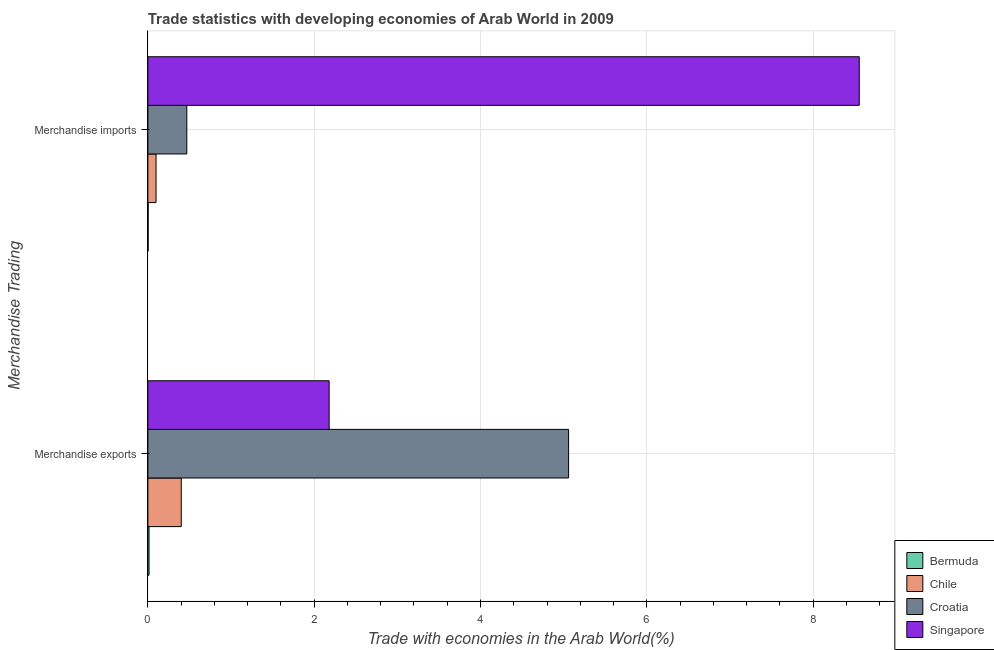How many different coloured bars are there?
Offer a terse response. 4. How many groups of bars are there?
Provide a succinct answer. 2. Are the number of bars per tick equal to the number of legend labels?
Offer a terse response. Yes. Are the number of bars on each tick of the Y-axis equal?
Your response must be concise. Yes. What is the label of the 2nd group of bars from the top?
Give a very brief answer. Merchandise exports. What is the merchandise exports in Croatia?
Give a very brief answer. 5.06. Across all countries, what is the maximum merchandise exports?
Give a very brief answer. 5.06. Across all countries, what is the minimum merchandise imports?
Offer a very short reply. 0. In which country was the merchandise exports maximum?
Your answer should be very brief. Croatia. In which country was the merchandise exports minimum?
Keep it short and to the point. Bermuda. What is the total merchandise exports in the graph?
Your response must be concise. 7.66. What is the difference between the merchandise exports in Croatia and that in Chile?
Your response must be concise. 4.66. What is the difference between the merchandise imports in Croatia and the merchandise exports in Bermuda?
Provide a succinct answer. 0.45. What is the average merchandise exports per country?
Give a very brief answer. 1.91. What is the difference between the merchandise exports and merchandise imports in Chile?
Provide a succinct answer. 0.3. In how many countries, is the merchandise imports greater than 8 %?
Ensure brevity in your answer.  1. What is the ratio of the merchandise exports in Chile to that in Croatia?
Provide a succinct answer. 0.08. Is the merchandise imports in Chile less than that in Croatia?
Ensure brevity in your answer.  Yes. In how many countries, is the merchandise imports greater than the average merchandise imports taken over all countries?
Your response must be concise. 1. What does the 1st bar from the top in Merchandise imports represents?
Ensure brevity in your answer.  Singapore. What does the 2nd bar from the bottom in Merchandise imports represents?
Keep it short and to the point. Chile. How many bars are there?
Make the answer very short. 8. How many countries are there in the graph?
Your response must be concise. 4. Are the values on the major ticks of X-axis written in scientific E-notation?
Provide a short and direct response. No. Does the graph contain grids?
Give a very brief answer. Yes. Where does the legend appear in the graph?
Ensure brevity in your answer.  Bottom right. How many legend labels are there?
Your response must be concise. 4. What is the title of the graph?
Give a very brief answer. Trade statistics with developing economies of Arab World in 2009. Does "Europe(all income levels)" appear as one of the legend labels in the graph?
Keep it short and to the point. No. What is the label or title of the X-axis?
Your response must be concise. Trade with economies in the Arab World(%). What is the label or title of the Y-axis?
Your answer should be compact. Merchandise Trading. What is the Trade with economies in the Arab World(%) of Bermuda in Merchandise exports?
Keep it short and to the point. 0.01. What is the Trade with economies in the Arab World(%) in Chile in Merchandise exports?
Offer a very short reply. 0.4. What is the Trade with economies in the Arab World(%) of Croatia in Merchandise exports?
Your answer should be compact. 5.06. What is the Trade with economies in the Arab World(%) in Singapore in Merchandise exports?
Offer a terse response. 2.18. What is the Trade with economies in the Arab World(%) of Bermuda in Merchandise imports?
Give a very brief answer. 0. What is the Trade with economies in the Arab World(%) of Chile in Merchandise imports?
Offer a terse response. 0.1. What is the Trade with economies in the Arab World(%) of Croatia in Merchandise imports?
Your answer should be compact. 0.47. What is the Trade with economies in the Arab World(%) in Singapore in Merchandise imports?
Your answer should be compact. 8.56. Across all Merchandise Trading, what is the maximum Trade with economies in the Arab World(%) of Bermuda?
Make the answer very short. 0.01. Across all Merchandise Trading, what is the maximum Trade with economies in the Arab World(%) in Chile?
Your answer should be compact. 0.4. Across all Merchandise Trading, what is the maximum Trade with economies in the Arab World(%) of Croatia?
Offer a terse response. 5.06. Across all Merchandise Trading, what is the maximum Trade with economies in the Arab World(%) in Singapore?
Provide a succinct answer. 8.56. Across all Merchandise Trading, what is the minimum Trade with economies in the Arab World(%) of Bermuda?
Ensure brevity in your answer.  0. Across all Merchandise Trading, what is the minimum Trade with economies in the Arab World(%) in Chile?
Make the answer very short. 0.1. Across all Merchandise Trading, what is the minimum Trade with economies in the Arab World(%) in Croatia?
Make the answer very short. 0.47. Across all Merchandise Trading, what is the minimum Trade with economies in the Arab World(%) in Singapore?
Make the answer very short. 2.18. What is the total Trade with economies in the Arab World(%) of Bermuda in the graph?
Ensure brevity in your answer.  0.02. What is the total Trade with economies in the Arab World(%) of Chile in the graph?
Keep it short and to the point. 0.5. What is the total Trade with economies in the Arab World(%) of Croatia in the graph?
Your response must be concise. 5.53. What is the total Trade with economies in the Arab World(%) of Singapore in the graph?
Provide a succinct answer. 10.74. What is the difference between the Trade with economies in the Arab World(%) in Bermuda in Merchandise exports and that in Merchandise imports?
Give a very brief answer. 0.01. What is the difference between the Trade with economies in the Arab World(%) in Chile in Merchandise exports and that in Merchandise imports?
Offer a very short reply. 0.3. What is the difference between the Trade with economies in the Arab World(%) of Croatia in Merchandise exports and that in Merchandise imports?
Your answer should be compact. 4.59. What is the difference between the Trade with economies in the Arab World(%) in Singapore in Merchandise exports and that in Merchandise imports?
Your answer should be compact. -6.38. What is the difference between the Trade with economies in the Arab World(%) of Bermuda in Merchandise exports and the Trade with economies in the Arab World(%) of Chile in Merchandise imports?
Your answer should be compact. -0.08. What is the difference between the Trade with economies in the Arab World(%) of Bermuda in Merchandise exports and the Trade with economies in the Arab World(%) of Croatia in Merchandise imports?
Provide a succinct answer. -0.45. What is the difference between the Trade with economies in the Arab World(%) of Bermuda in Merchandise exports and the Trade with economies in the Arab World(%) of Singapore in Merchandise imports?
Make the answer very short. -8.54. What is the difference between the Trade with economies in the Arab World(%) of Chile in Merchandise exports and the Trade with economies in the Arab World(%) of Croatia in Merchandise imports?
Your response must be concise. -0.07. What is the difference between the Trade with economies in the Arab World(%) in Chile in Merchandise exports and the Trade with economies in the Arab World(%) in Singapore in Merchandise imports?
Offer a terse response. -8.15. What is the difference between the Trade with economies in the Arab World(%) of Croatia in Merchandise exports and the Trade with economies in the Arab World(%) of Singapore in Merchandise imports?
Your answer should be compact. -3.5. What is the average Trade with economies in the Arab World(%) of Bermuda per Merchandise Trading?
Your response must be concise. 0.01. What is the average Trade with economies in the Arab World(%) in Chile per Merchandise Trading?
Your response must be concise. 0.25. What is the average Trade with economies in the Arab World(%) of Croatia per Merchandise Trading?
Your answer should be compact. 2.76. What is the average Trade with economies in the Arab World(%) of Singapore per Merchandise Trading?
Provide a succinct answer. 5.37. What is the difference between the Trade with economies in the Arab World(%) of Bermuda and Trade with economies in the Arab World(%) of Chile in Merchandise exports?
Offer a terse response. -0.39. What is the difference between the Trade with economies in the Arab World(%) in Bermuda and Trade with economies in the Arab World(%) in Croatia in Merchandise exports?
Your answer should be compact. -5.05. What is the difference between the Trade with economies in the Arab World(%) of Bermuda and Trade with economies in the Arab World(%) of Singapore in Merchandise exports?
Offer a terse response. -2.17. What is the difference between the Trade with economies in the Arab World(%) in Chile and Trade with economies in the Arab World(%) in Croatia in Merchandise exports?
Your response must be concise. -4.66. What is the difference between the Trade with economies in the Arab World(%) in Chile and Trade with economies in the Arab World(%) in Singapore in Merchandise exports?
Ensure brevity in your answer.  -1.78. What is the difference between the Trade with economies in the Arab World(%) in Croatia and Trade with economies in the Arab World(%) in Singapore in Merchandise exports?
Offer a very short reply. 2.88. What is the difference between the Trade with economies in the Arab World(%) of Bermuda and Trade with economies in the Arab World(%) of Chile in Merchandise imports?
Provide a succinct answer. -0.09. What is the difference between the Trade with economies in the Arab World(%) in Bermuda and Trade with economies in the Arab World(%) in Croatia in Merchandise imports?
Your answer should be compact. -0.46. What is the difference between the Trade with economies in the Arab World(%) in Bermuda and Trade with economies in the Arab World(%) in Singapore in Merchandise imports?
Keep it short and to the point. -8.55. What is the difference between the Trade with economies in the Arab World(%) in Chile and Trade with economies in the Arab World(%) in Croatia in Merchandise imports?
Your response must be concise. -0.37. What is the difference between the Trade with economies in the Arab World(%) of Chile and Trade with economies in the Arab World(%) of Singapore in Merchandise imports?
Your answer should be very brief. -8.46. What is the difference between the Trade with economies in the Arab World(%) of Croatia and Trade with economies in the Arab World(%) of Singapore in Merchandise imports?
Offer a terse response. -8.09. What is the ratio of the Trade with economies in the Arab World(%) in Bermuda in Merchandise exports to that in Merchandise imports?
Ensure brevity in your answer.  4.06. What is the ratio of the Trade with economies in the Arab World(%) in Chile in Merchandise exports to that in Merchandise imports?
Offer a terse response. 4.08. What is the ratio of the Trade with economies in the Arab World(%) in Croatia in Merchandise exports to that in Merchandise imports?
Keep it short and to the point. 10.8. What is the ratio of the Trade with economies in the Arab World(%) in Singapore in Merchandise exports to that in Merchandise imports?
Make the answer very short. 0.25. What is the difference between the highest and the second highest Trade with economies in the Arab World(%) of Bermuda?
Ensure brevity in your answer.  0.01. What is the difference between the highest and the second highest Trade with economies in the Arab World(%) of Chile?
Offer a very short reply. 0.3. What is the difference between the highest and the second highest Trade with economies in the Arab World(%) in Croatia?
Your answer should be compact. 4.59. What is the difference between the highest and the second highest Trade with economies in the Arab World(%) in Singapore?
Provide a short and direct response. 6.38. What is the difference between the highest and the lowest Trade with economies in the Arab World(%) in Bermuda?
Offer a terse response. 0.01. What is the difference between the highest and the lowest Trade with economies in the Arab World(%) of Chile?
Provide a succinct answer. 0.3. What is the difference between the highest and the lowest Trade with economies in the Arab World(%) of Croatia?
Make the answer very short. 4.59. What is the difference between the highest and the lowest Trade with economies in the Arab World(%) of Singapore?
Your answer should be very brief. 6.38. 